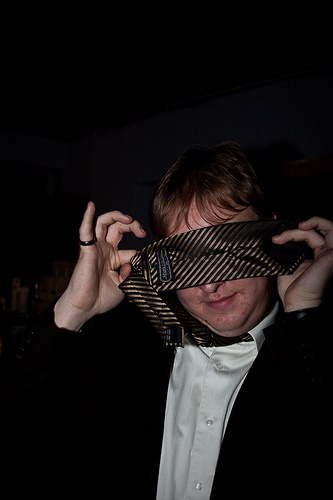Describe the objects in this image and their specific colors. I can see people in black, darkgray, gray, and maroon tones and tie in black and gray tones in this image. 